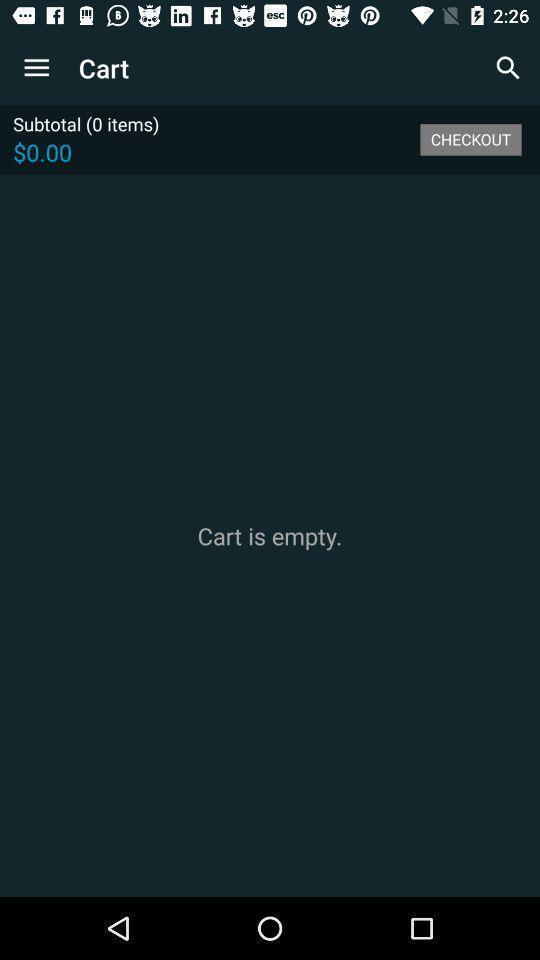Describe the visual elements of this screenshot. Page is showing cart is empty. 